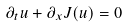Convert formula to latex. <formula><loc_0><loc_0><loc_500><loc_500>\partial _ { t } u + \partial _ { x } J ( u ) = 0</formula> 